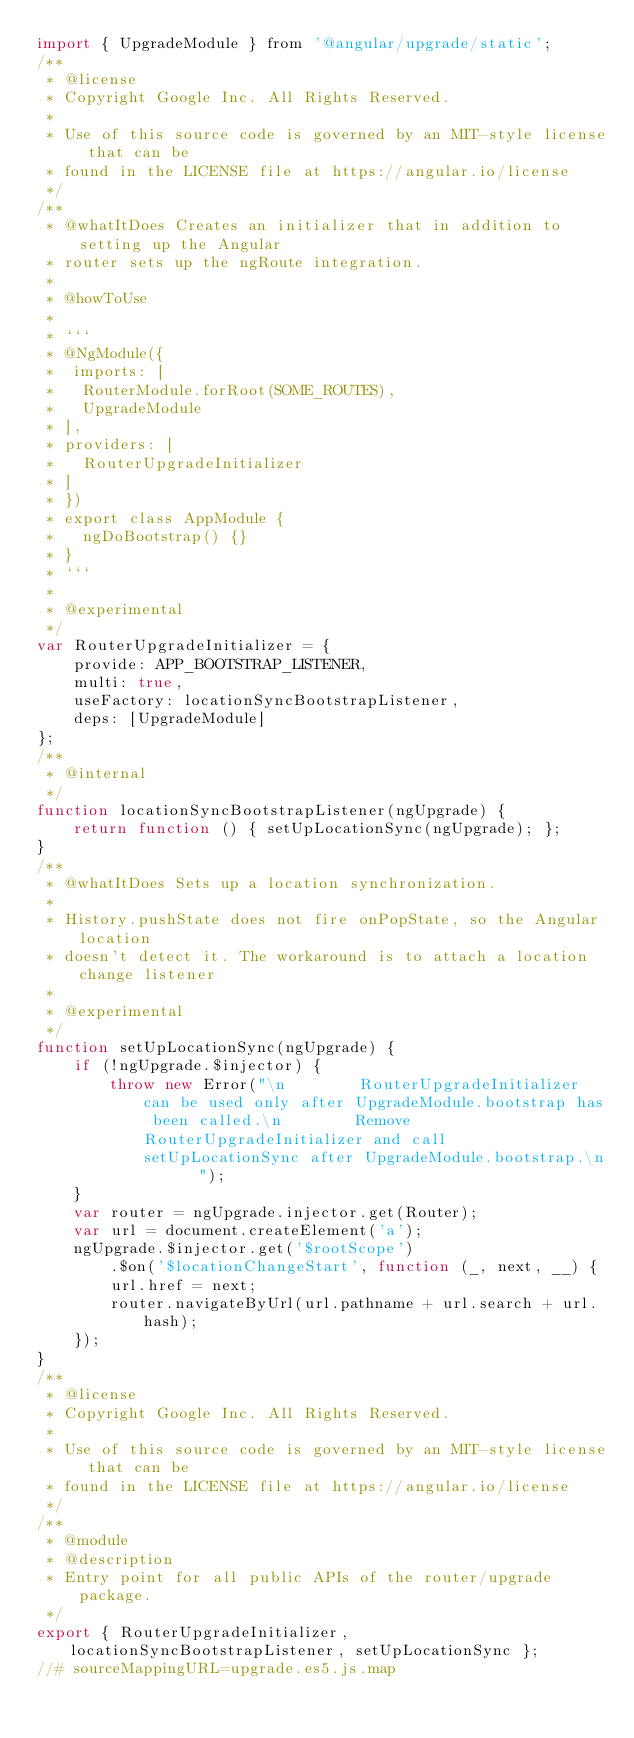Convert code to text. <code><loc_0><loc_0><loc_500><loc_500><_JavaScript_>import { UpgradeModule } from '@angular/upgrade/static';
/**
 * @license
 * Copyright Google Inc. All Rights Reserved.
 *
 * Use of this source code is governed by an MIT-style license that can be
 * found in the LICENSE file at https://angular.io/license
 */
/**
 * @whatItDoes Creates an initializer that in addition to setting up the Angular
 * router sets up the ngRoute integration.
 *
 * @howToUse
 *
 * ```
 * @NgModule({
 *  imports: [
 *   RouterModule.forRoot(SOME_ROUTES),
 *   UpgradeModule
 * ],
 * providers: [
 *   RouterUpgradeInitializer
 * ]
 * })
 * export class AppModule {
 *   ngDoBootstrap() {}
 * }
 * ```
 *
 * @experimental
 */
var RouterUpgradeInitializer = {
    provide: APP_BOOTSTRAP_LISTENER,
    multi: true,
    useFactory: locationSyncBootstrapListener,
    deps: [UpgradeModule]
};
/**
 * @internal
 */
function locationSyncBootstrapListener(ngUpgrade) {
    return function () { setUpLocationSync(ngUpgrade); };
}
/**
 * @whatItDoes Sets up a location synchronization.
 *
 * History.pushState does not fire onPopState, so the Angular location
 * doesn't detect it. The workaround is to attach a location change listener
 *
 * @experimental
 */
function setUpLocationSync(ngUpgrade) {
    if (!ngUpgrade.$injector) {
        throw new Error("\n        RouterUpgradeInitializer can be used only after UpgradeModule.bootstrap has been called.\n        Remove RouterUpgradeInitializer and call setUpLocationSync after UpgradeModule.bootstrap.\n      ");
    }
    var router = ngUpgrade.injector.get(Router);
    var url = document.createElement('a');
    ngUpgrade.$injector.get('$rootScope')
        .$on('$locationChangeStart', function (_, next, __) {
        url.href = next;
        router.navigateByUrl(url.pathname + url.search + url.hash);
    });
}
/**
 * @license
 * Copyright Google Inc. All Rights Reserved.
 *
 * Use of this source code is governed by an MIT-style license that can be
 * found in the LICENSE file at https://angular.io/license
 */
/**
 * @module
 * @description
 * Entry point for all public APIs of the router/upgrade package.
 */
export { RouterUpgradeInitializer, locationSyncBootstrapListener, setUpLocationSync };
//# sourceMappingURL=upgrade.es5.js.map
</code> 